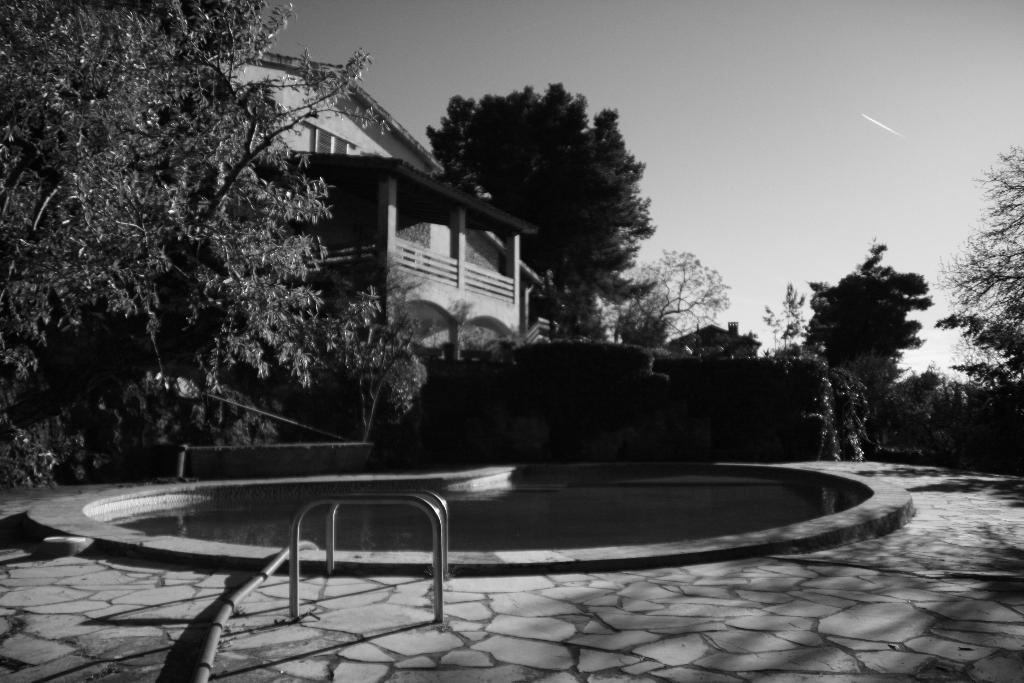What objects are located in the front of the image? There are rods in the front of the image. What is in the center of the image? There is water in the center of the image. What can be seen in the background of the image? There are trees and a building in the background of the image. How many windows can be seen on the trees in the background of the image? There are no windows present on the trees in the image; trees do not have windows. What type of twig is being used to act as a conductor in the image? There is no twig or act of conducting present in the image. 